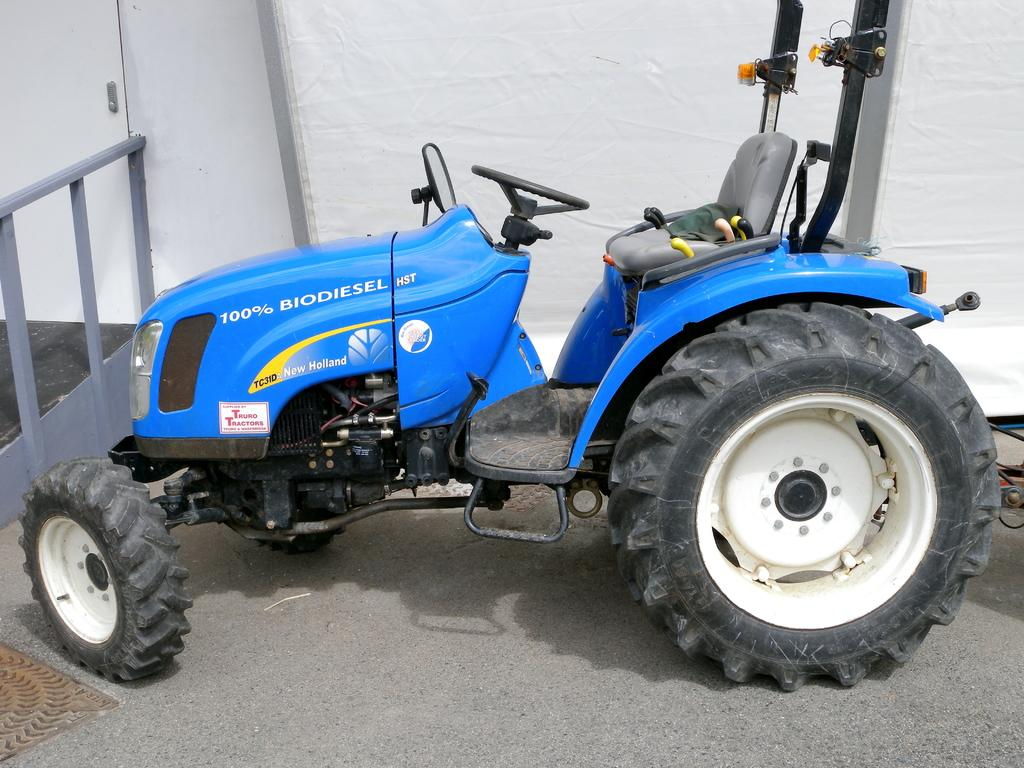What is the main subject in the center of the image? There is a tractor in the center of the image. What can be seen in the background of the image? There is a wall and a door in the background of the image. What is on the left side of the image? There is a fence on the left side of the image. What is at the bottom of the image? There is a walkway at the bottom of the image. Where is the hall located in the image? There is no hall present in the image. Is there a scarf being used as a prop in the image? There is no scarf present in the image. 